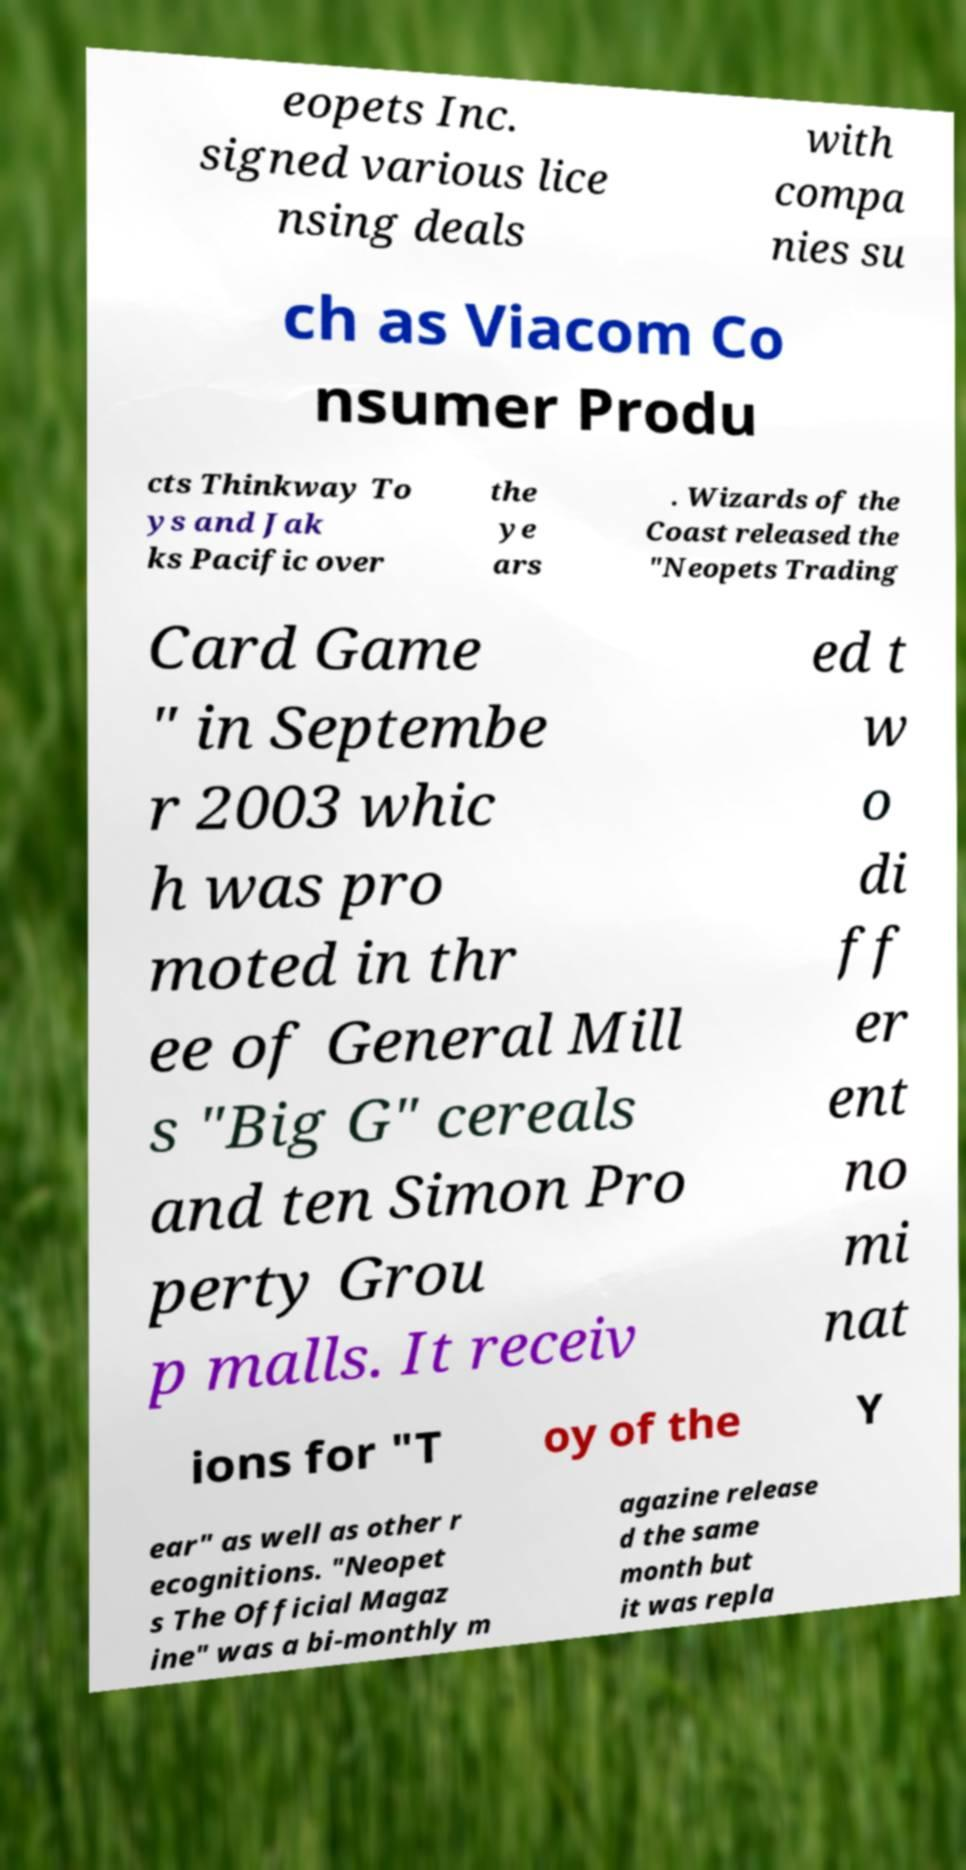For documentation purposes, I need the text within this image transcribed. Could you provide that? eopets Inc. signed various lice nsing deals with compa nies su ch as Viacom Co nsumer Produ cts Thinkway To ys and Jak ks Pacific over the ye ars . Wizards of the Coast released the "Neopets Trading Card Game " in Septembe r 2003 whic h was pro moted in thr ee of General Mill s "Big G" cereals and ten Simon Pro perty Grou p malls. It receiv ed t w o di ff er ent no mi nat ions for "T oy of the Y ear" as well as other r ecognitions. "Neopet s The Official Magaz ine" was a bi-monthly m agazine release d the same month but it was repla 